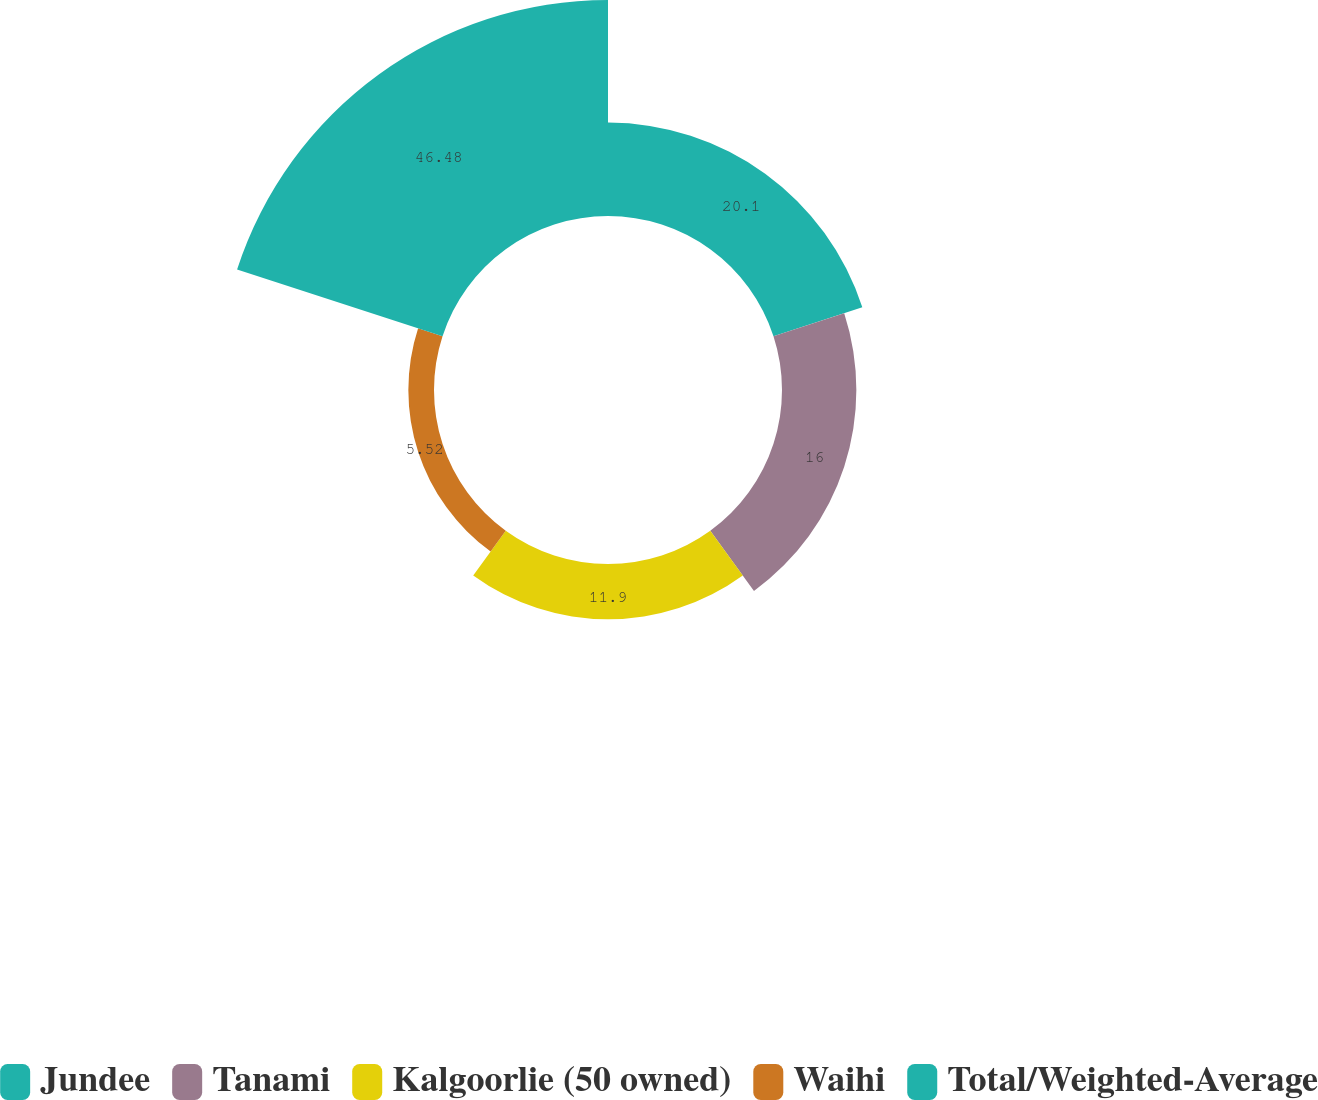Convert chart to OTSL. <chart><loc_0><loc_0><loc_500><loc_500><pie_chart><fcel>Jundee<fcel>Tanami<fcel>Kalgoorlie (50 owned)<fcel>Waihi<fcel>Total/Weighted-Average<nl><fcel>20.1%<fcel>16.0%<fcel>11.9%<fcel>5.52%<fcel>46.48%<nl></chart> 